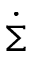Convert formula to latex. <formula><loc_0><loc_0><loc_500><loc_500>\dot { \Sigma }</formula> 